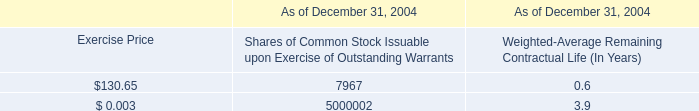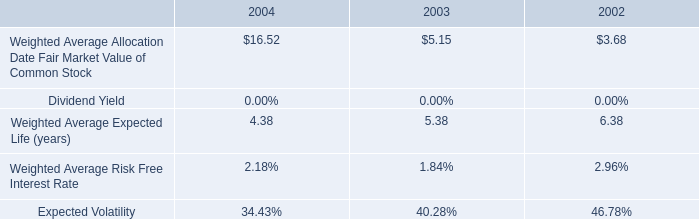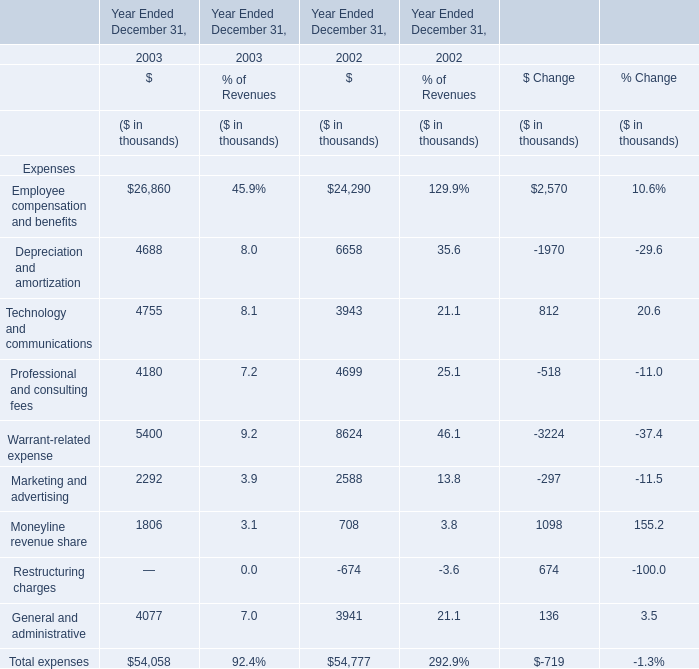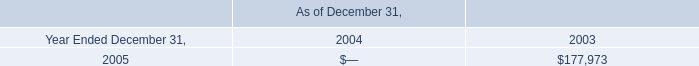as of december 31 , 2004 , what percentage of common stock outstanding were non-voting shares? 
Computations: (10000000 / (110000000 + 10000000))
Answer: 0.08333. 